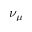<formula> <loc_0><loc_0><loc_500><loc_500>\nu _ { \mu }</formula> 